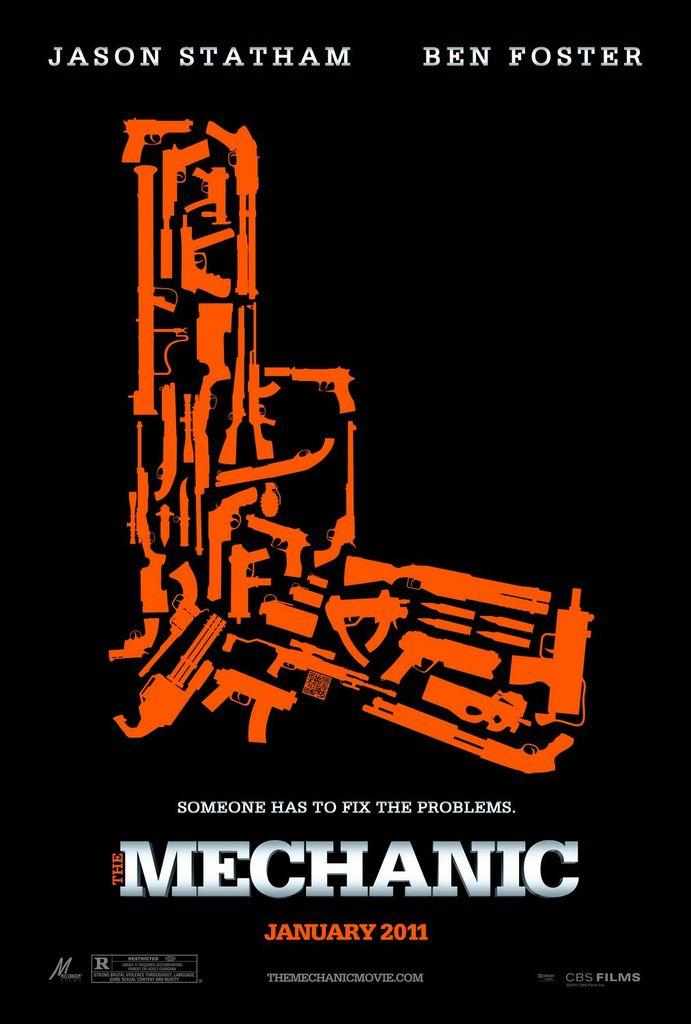<image>
Provide a brief description of the given image. The film shown stars actors Ben Foster and Jason Statham. 